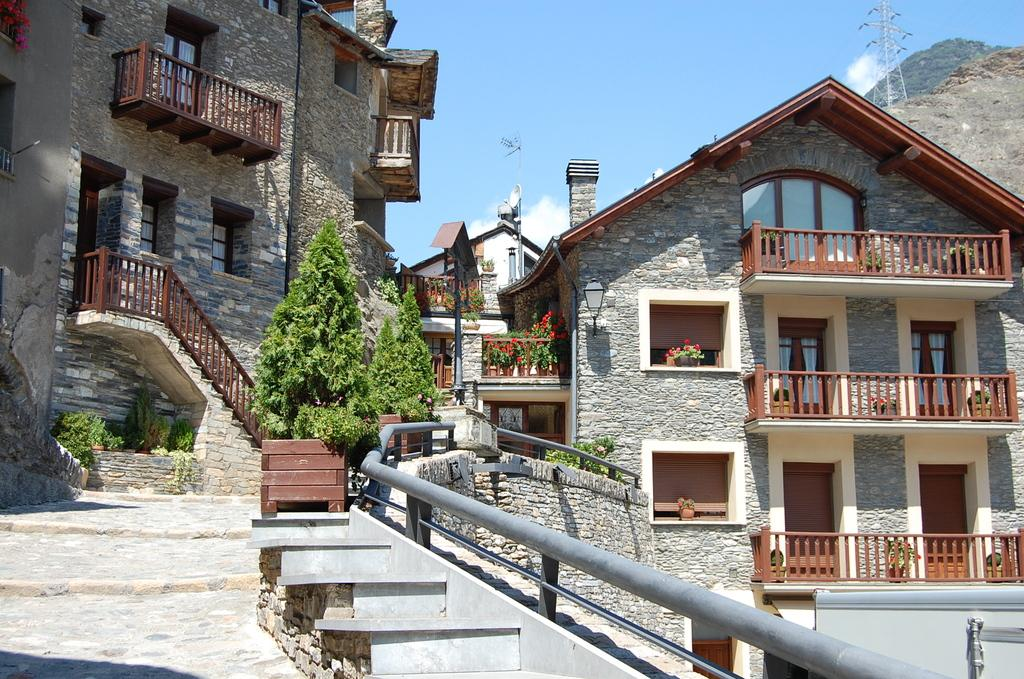What type of structure can be seen in the image? There are stairs, buildings with windows, and a tower in the image. What other elements are present in the image? There are plants and a mountain covered with trees at the right side of the image. How is the sky depicted in the image? The sky is clear in the image. What book is your dad reading on the street in the image? There is no reference to a dad, reading, or street in the image. The image features stairs, buildings, plants, a tower, a mountain, and a clear sky. 